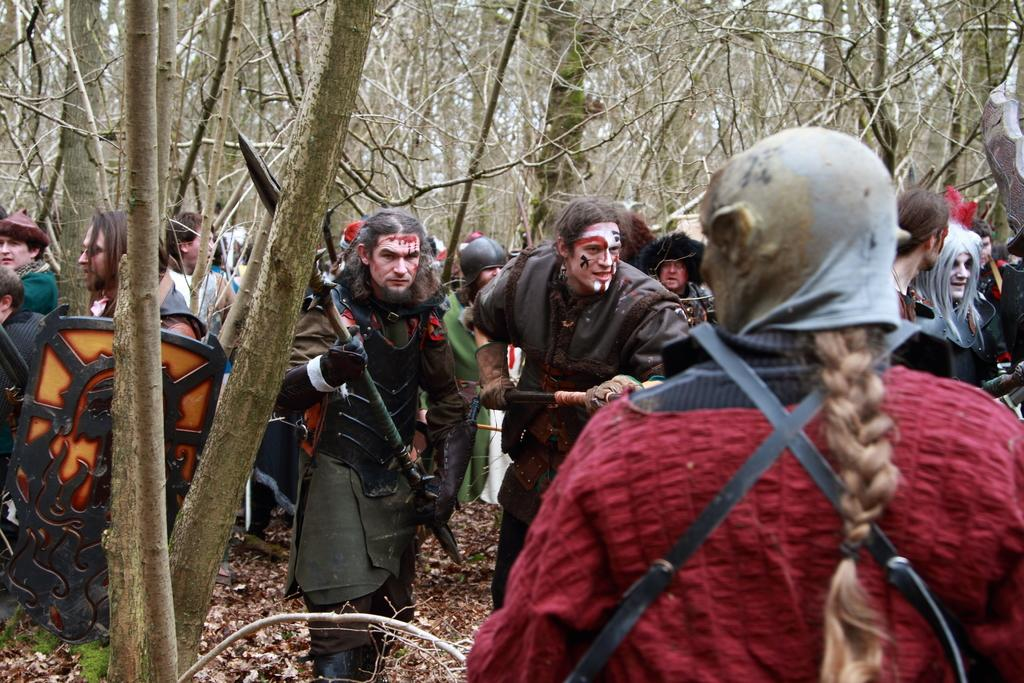What are the people in the image doing? The people in the image are standing on the ground. What are the people holding in their hands? The people are holding objects. What can be seen in the background of the image? There are trees in the background of the image. How many oranges are hanging from the trees in the image? There are no oranges visible in the image; only trees can be seen in the background. 